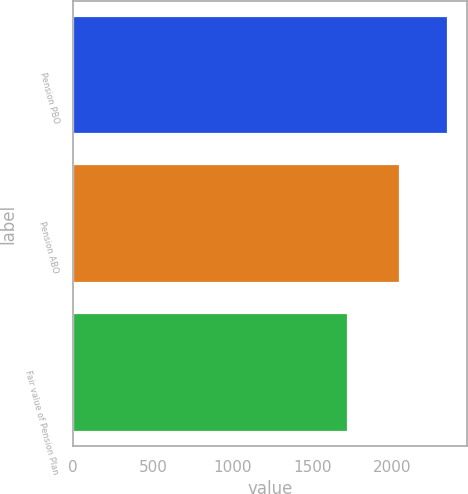<chart> <loc_0><loc_0><loc_500><loc_500><bar_chart><fcel>Pension PBO<fcel>Pension ABO<fcel>Fair value of Pension Plan<nl><fcel>2354<fcel>2054<fcel>1727<nl></chart> 